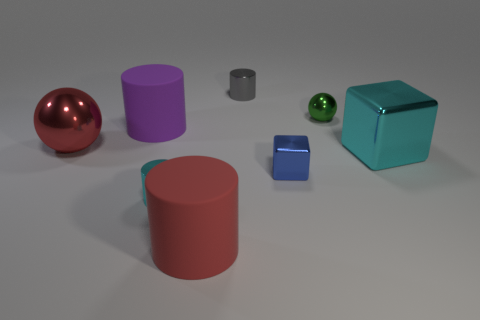How many big things are either gray objects or red shiny cubes?
Your answer should be compact. 0. Are there more purple matte cylinders than large gray metallic balls?
Ensure brevity in your answer.  Yes. Is the material of the large purple cylinder the same as the big cyan object?
Provide a succinct answer. No. Is there anything else that has the same material as the gray object?
Ensure brevity in your answer.  Yes. Are there more large rubber things that are on the left side of the tiny cyan metallic cylinder than small red matte blocks?
Keep it short and to the point. Yes. Do the tiny metal block and the big metal ball have the same color?
Ensure brevity in your answer.  No. What number of blue shiny things have the same shape as the large red rubber object?
Give a very brief answer. 0. There is a gray object that is the same material as the small green object; what size is it?
Ensure brevity in your answer.  Small. There is a small metal thing that is both behind the small blue cube and right of the gray metallic cylinder; what color is it?
Your answer should be compact. Green. What number of gray cylinders are the same size as the red cylinder?
Ensure brevity in your answer.  0. 